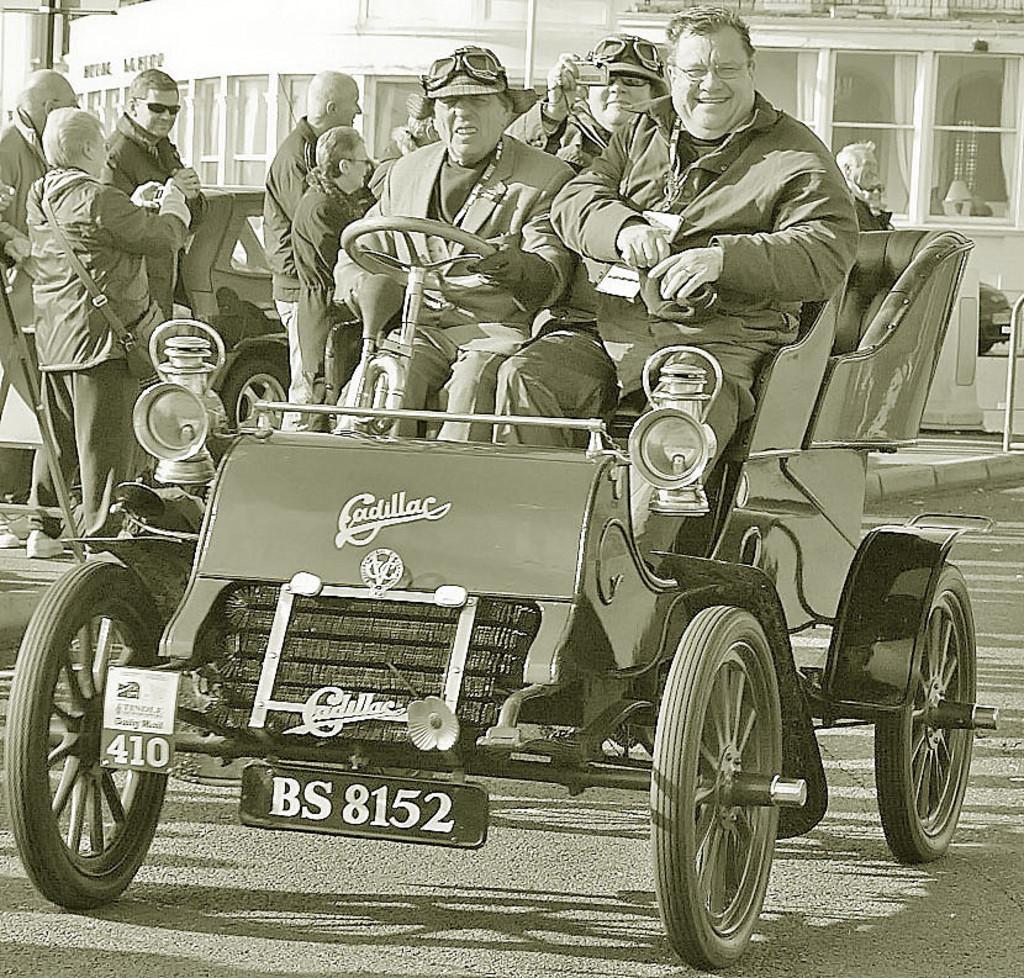Please provide a concise description of this image. As we can see in the image there is a building, car, few people here and there and a truck. 